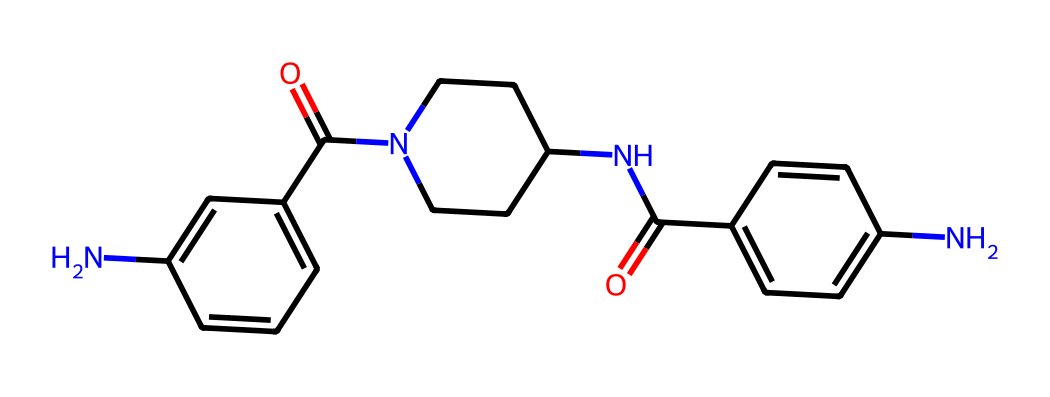What is the primary functional group present in this chemical? The chemical features an amide linkage (R-C(=O)-NR2) indicated by the presence of carbonyl (C=O) connected to a nitrogen (N). This is characteristic of amides, which are key functional groups in polymers like aramid.
Answer: amide How many nitrogen atoms are in the molecular structure? By examining the structure, there are three distinct nitrogen atoms represented in different parts of the chain, which are part of the amide and piperidine groups.
Answer: three What type of polymer does this molecule represent? The structure illustrates characteristics of aromatic polyamide, known as aramid, due to its repeating units of amides linked through aromatic rings, which provides high strength and thermal stability.
Answer: aramid What is the total count of double bonds present in the structure? Upon analyzing the structure, there are three double bonds seen in the aromatic rings (C=C) and the carbonyl group (C=O), leading to a total of four double bonds within the molecule.
Answer: four What is the significance of the aromatic rings in this fiber? The presence of aromatic rings contributes to the rigidity and strength of the polymer, enhancing thermal resistance and mechanical properties crucial for applications like bulletproof vests, improving durability under stress.
Answer: rigidity What role does the piperidine ring play in this structure? The piperidine ring is likely to provide flexibility and impact resistance to the fiber, as its cyclic structure allows for some rotation and hence contributes to the overall mechanical properties of the aramid fiber.
Answer: flexibility 